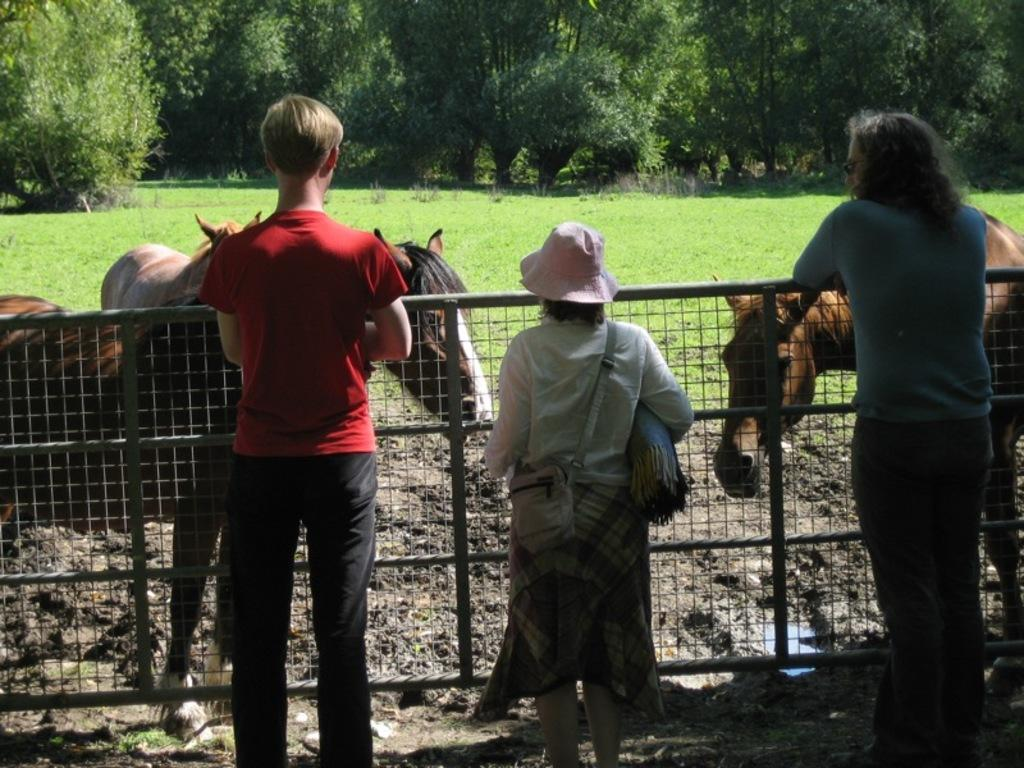How many persons are standing in the image? There are three persons standing in the image. What is unique about the middle person's attire? The middle person is wearing a hat and a bag. What is in front of the persons? There is a fencing in front of the persons. What animals are present in the image? There are horses present in the image. What can be seen in the background of the image? There is a grass lawn and trees in the background. What type of pollution can be seen in the image? There is no pollution visible in the image. What discovery was made by the persons in the image? There is no indication of a discovery being made in the image. 